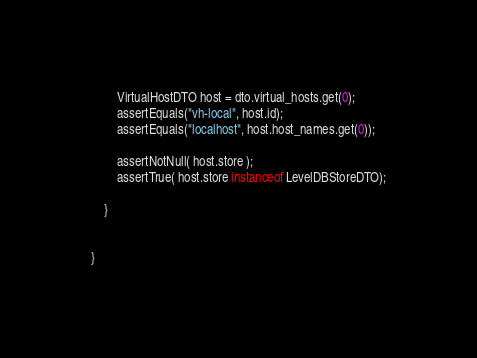<code> <loc_0><loc_0><loc_500><loc_500><_Java_>        VirtualHostDTO host = dto.virtual_hosts.get(0);
        assertEquals("vh-local", host.id);
        assertEquals("localhost", host.host_names.get(0));

        assertNotNull( host.store );
        assertTrue( host.store instanceof LevelDBStoreDTO);

    }


}
</code> 